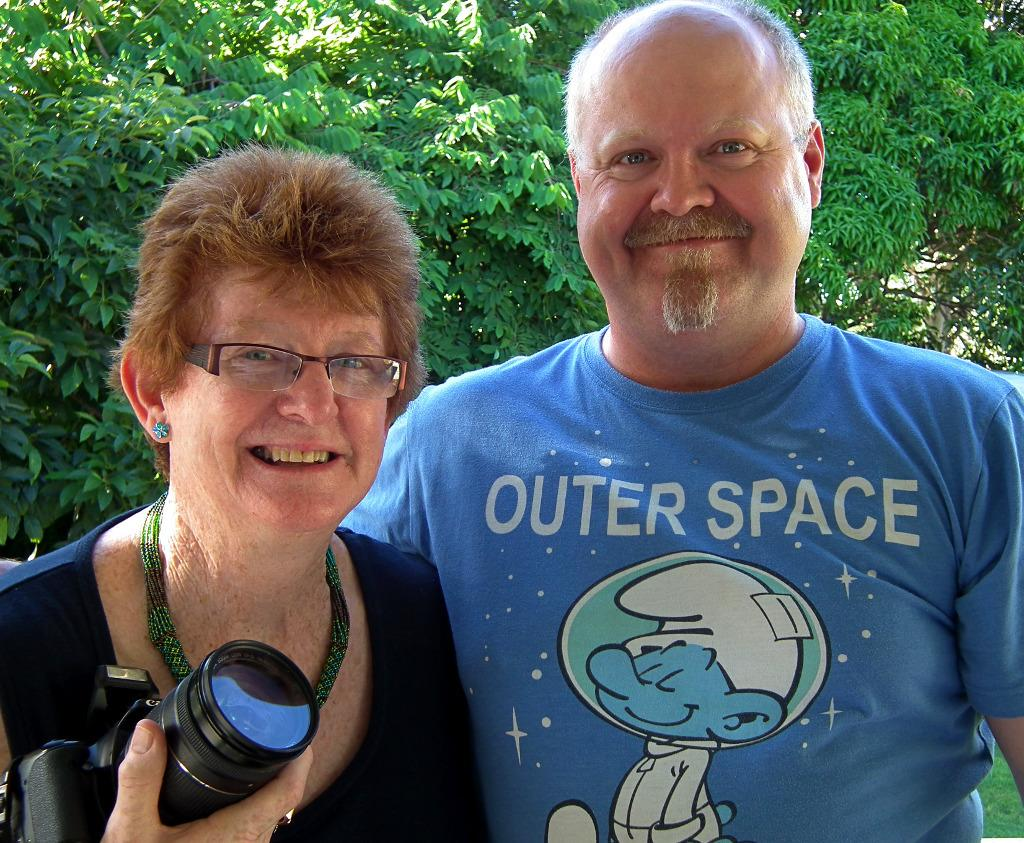How many people are present in the image? There are two people in the image, a man and a woman. What is the woman holding in the image? The woman is holding a camera. What can be seen in the background of the image? There are green trees in the background of the image. What type of salt can be seen on the train tracks in the image? There is no train or salt present in the image; it features a man and a woman with green trees in the background. 